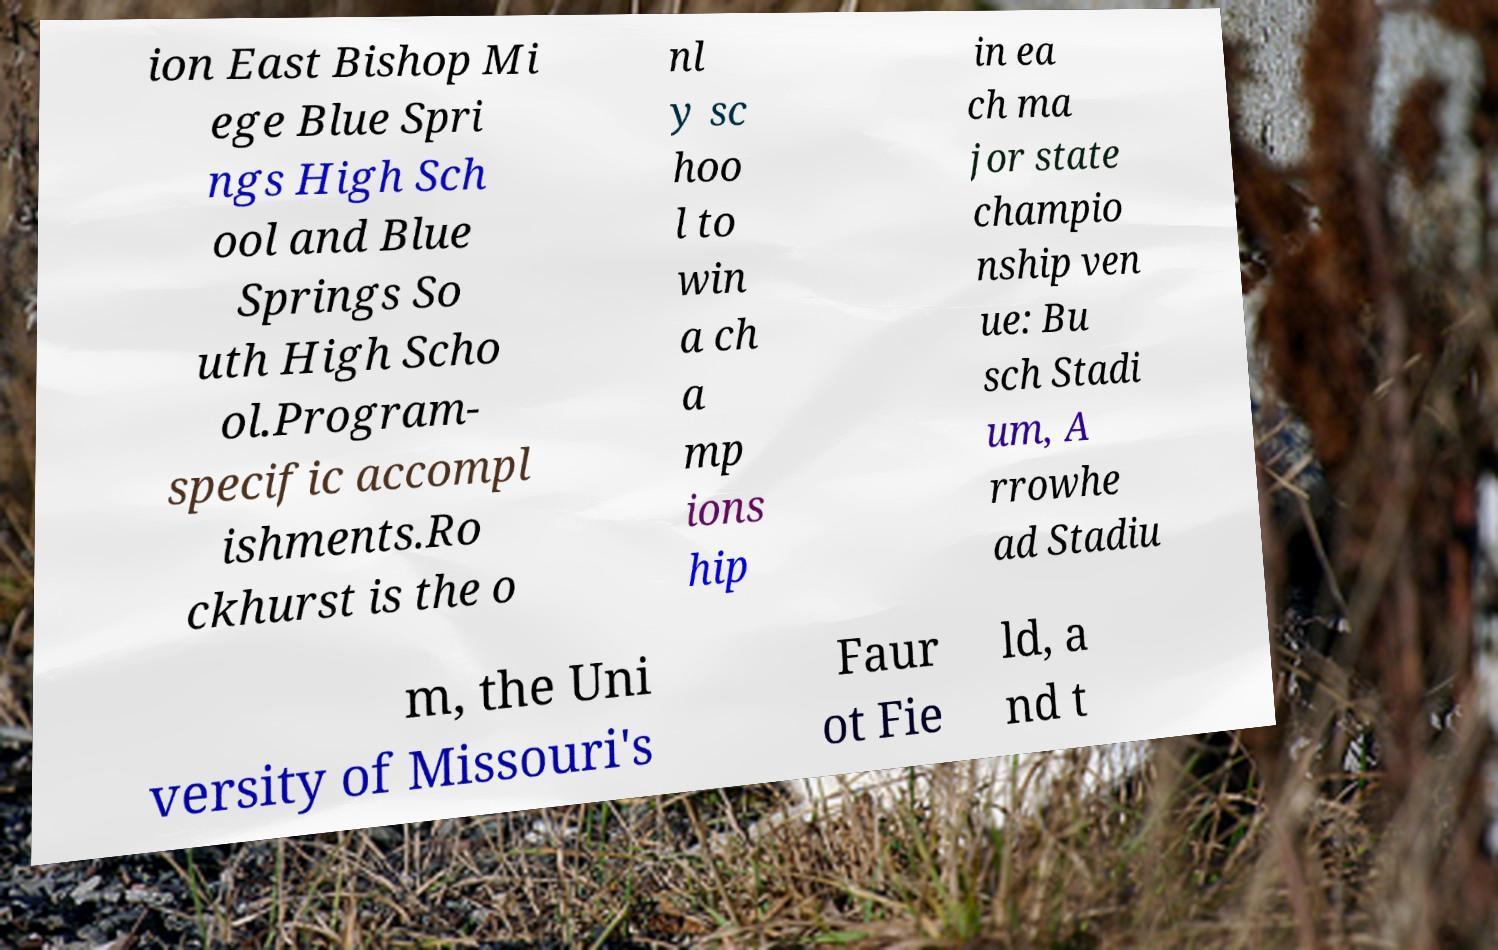Could you assist in decoding the text presented in this image and type it out clearly? ion East Bishop Mi ege Blue Spri ngs High Sch ool and Blue Springs So uth High Scho ol.Program- specific accompl ishments.Ro ckhurst is the o nl y sc hoo l to win a ch a mp ions hip in ea ch ma jor state champio nship ven ue: Bu sch Stadi um, A rrowhe ad Stadiu m, the Uni versity of Missouri's Faur ot Fie ld, a nd t 